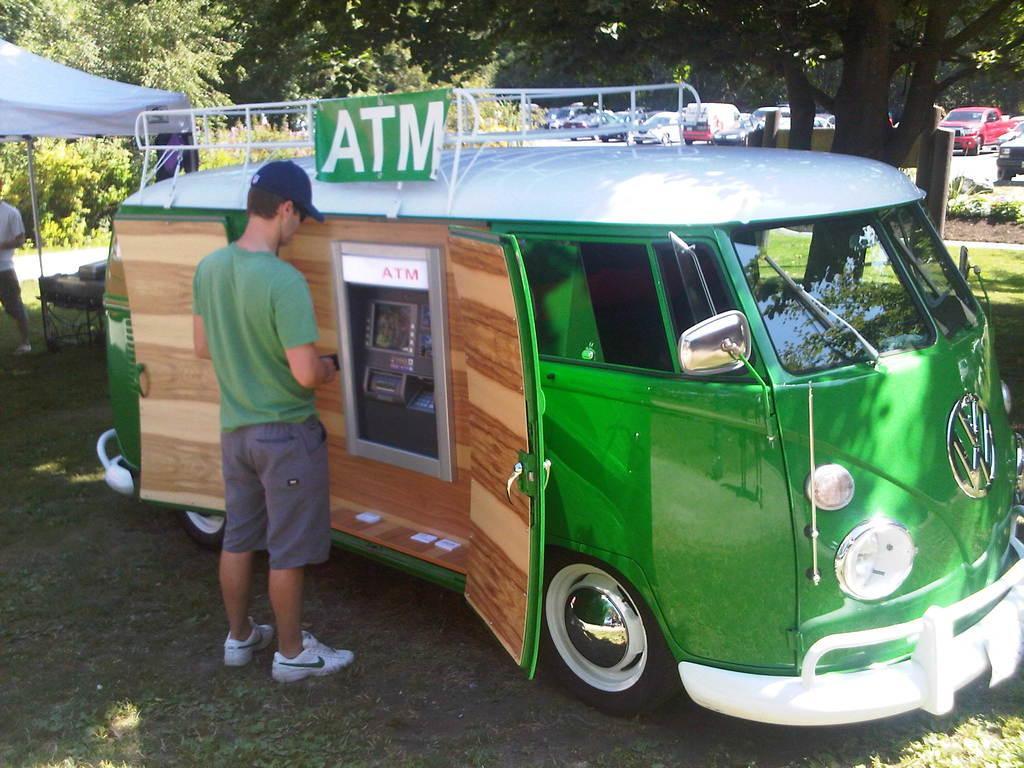Can you describe this image briefly? In this picture there is a man standing, in front of him we can see a vehicle and board attached to the rods. In the background of the image we can see trees and vehicles. On the left side of the image there is a person standing and we can see text and objects. 